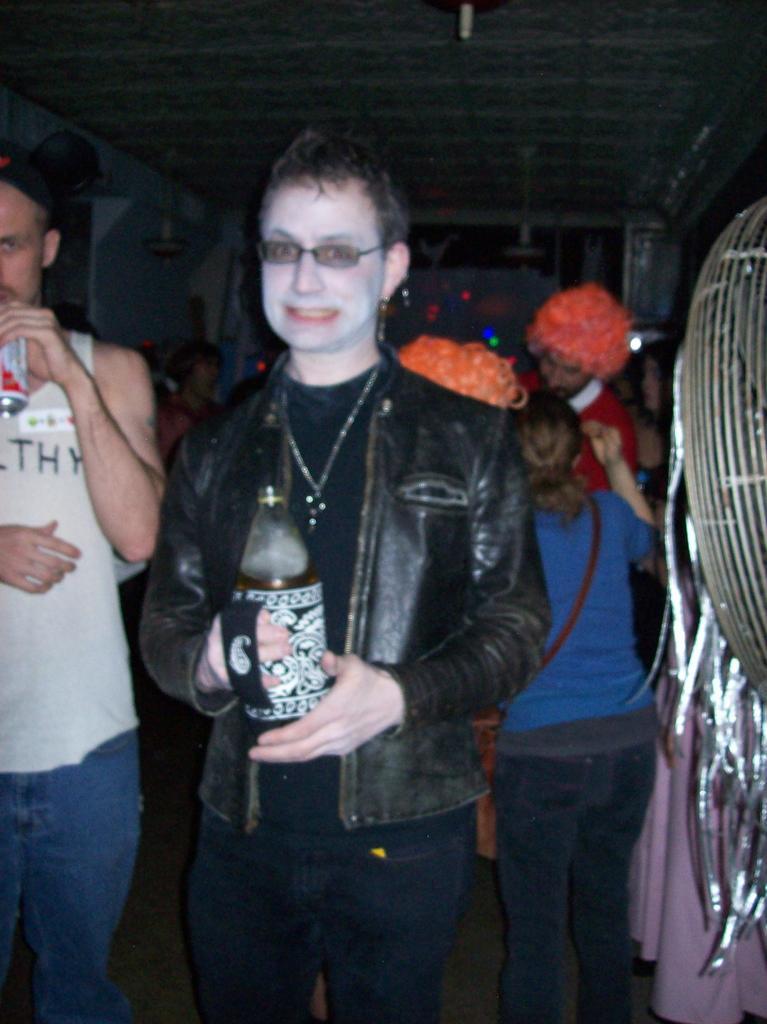Could you give a brief overview of what you see in this image? In the picture we can see a woman standing with a bottle in her hand and she is wearing a black color jacket and a necklace and in the background, we can see some people are standing and wearing a different types of caps. 